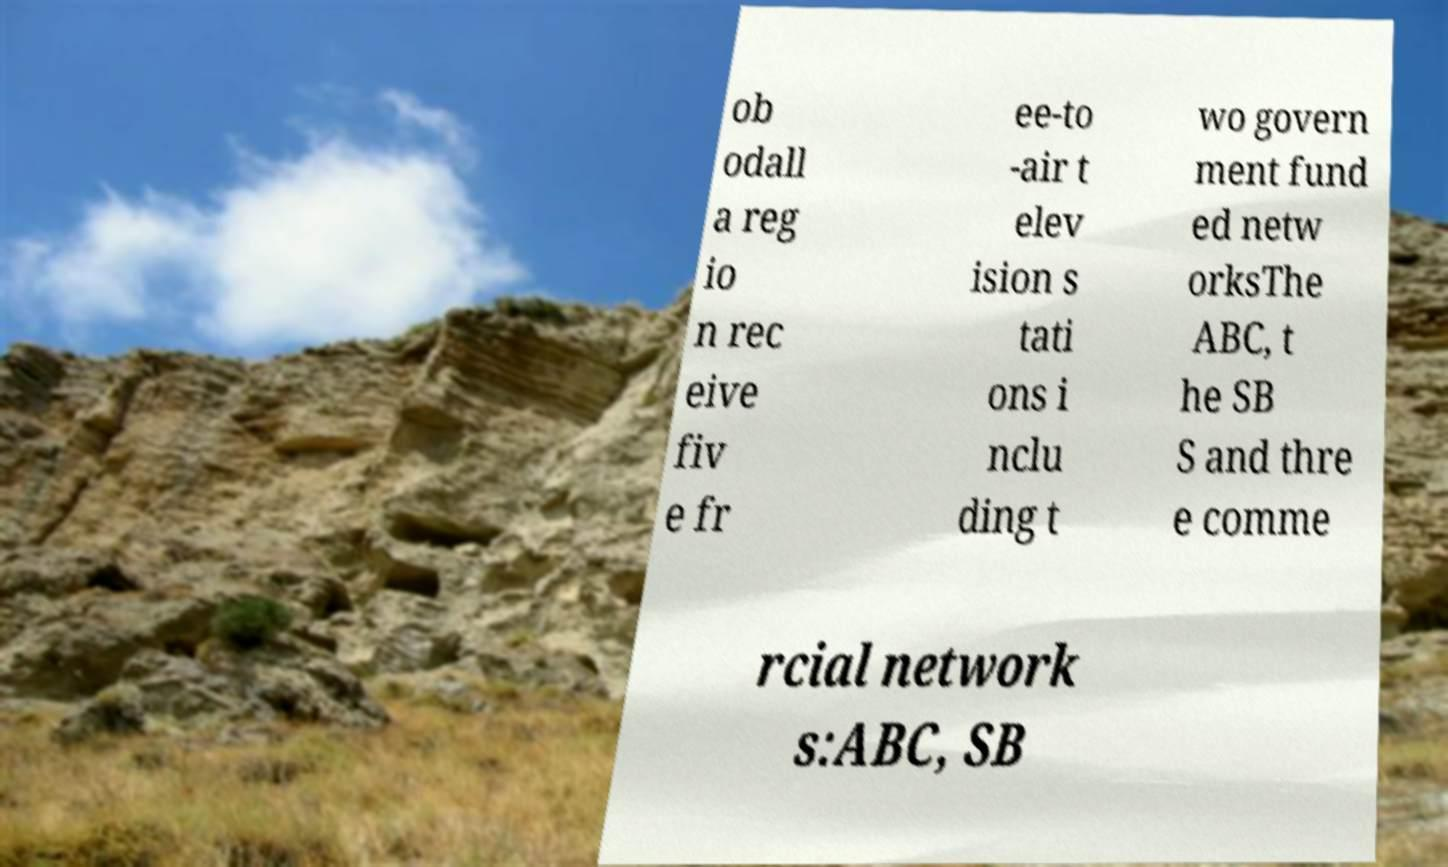Can you read and provide the text displayed in the image?This photo seems to have some interesting text. Can you extract and type it out for me? ob odall a reg io n rec eive fiv e fr ee-to -air t elev ision s tati ons i nclu ding t wo govern ment fund ed netw orksThe ABC, t he SB S and thre e comme rcial network s:ABC, SB 